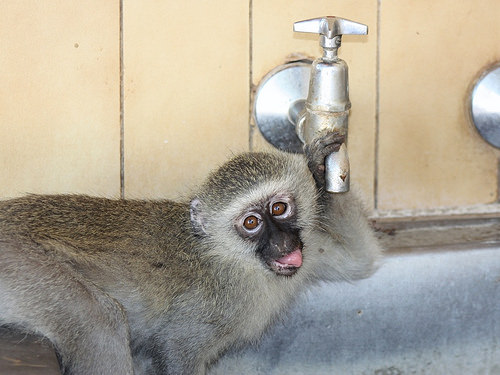<image>
Is the monkey under the faucet? Yes. The monkey is positioned underneath the faucet, with the faucet above it in the vertical space. 